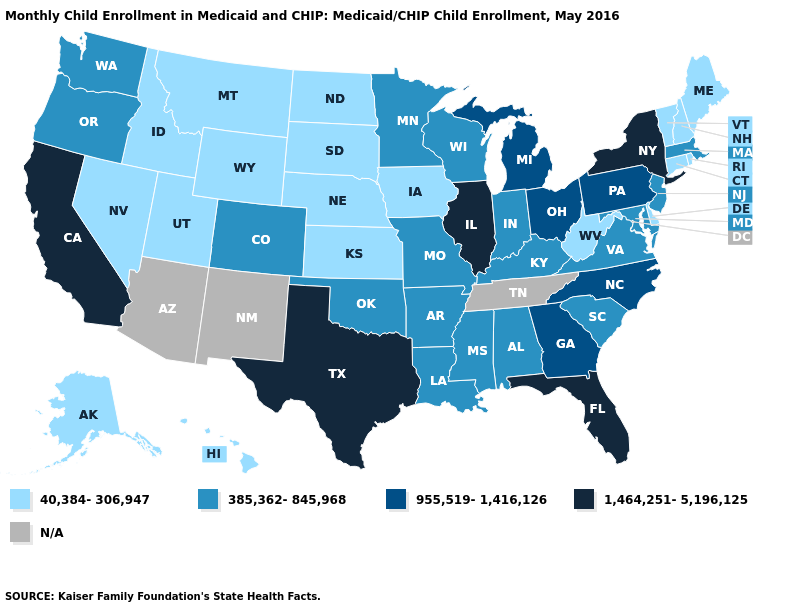What is the lowest value in the West?
Be succinct. 40,384-306,947. Which states have the lowest value in the USA?
Answer briefly. Alaska, Connecticut, Delaware, Hawaii, Idaho, Iowa, Kansas, Maine, Montana, Nebraska, Nevada, New Hampshire, North Dakota, Rhode Island, South Dakota, Utah, Vermont, West Virginia, Wyoming. What is the lowest value in the Northeast?
Quick response, please. 40,384-306,947. What is the lowest value in the USA?
Short answer required. 40,384-306,947. Name the states that have a value in the range 1,464,251-5,196,125?
Write a very short answer. California, Florida, Illinois, New York, Texas. Name the states that have a value in the range N/A?
Short answer required. Arizona, New Mexico, Tennessee. Among the states that border New York , does Connecticut have the highest value?
Short answer required. No. What is the highest value in states that border Rhode Island?
Quick response, please. 385,362-845,968. What is the value of Connecticut?
Be succinct. 40,384-306,947. Does the map have missing data?
Write a very short answer. Yes. Among the states that border North Carolina , which have the highest value?
Give a very brief answer. Georgia. Does New Jersey have the highest value in the Northeast?
Be succinct. No. Among the states that border Vermont , does New York have the highest value?
Write a very short answer. Yes. What is the lowest value in the South?
Write a very short answer. 40,384-306,947. What is the value of Rhode Island?
Be succinct. 40,384-306,947. 